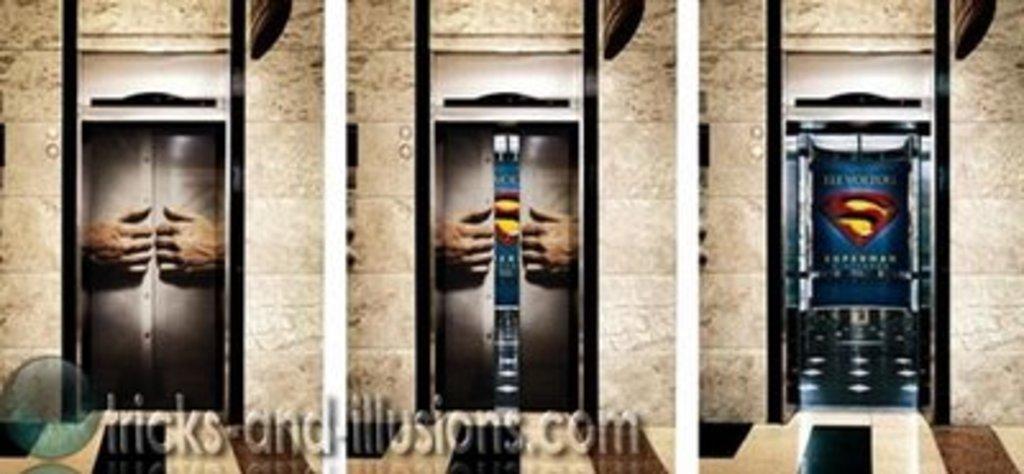Describe this image in one or two sentences. It is the photo collage, in this on the left side there are 2 hands that are trying to open the door. In the middle these are two hands that are trying to open the door, in this image there is a super man symbol. In this at the bottom there is the watermark. 